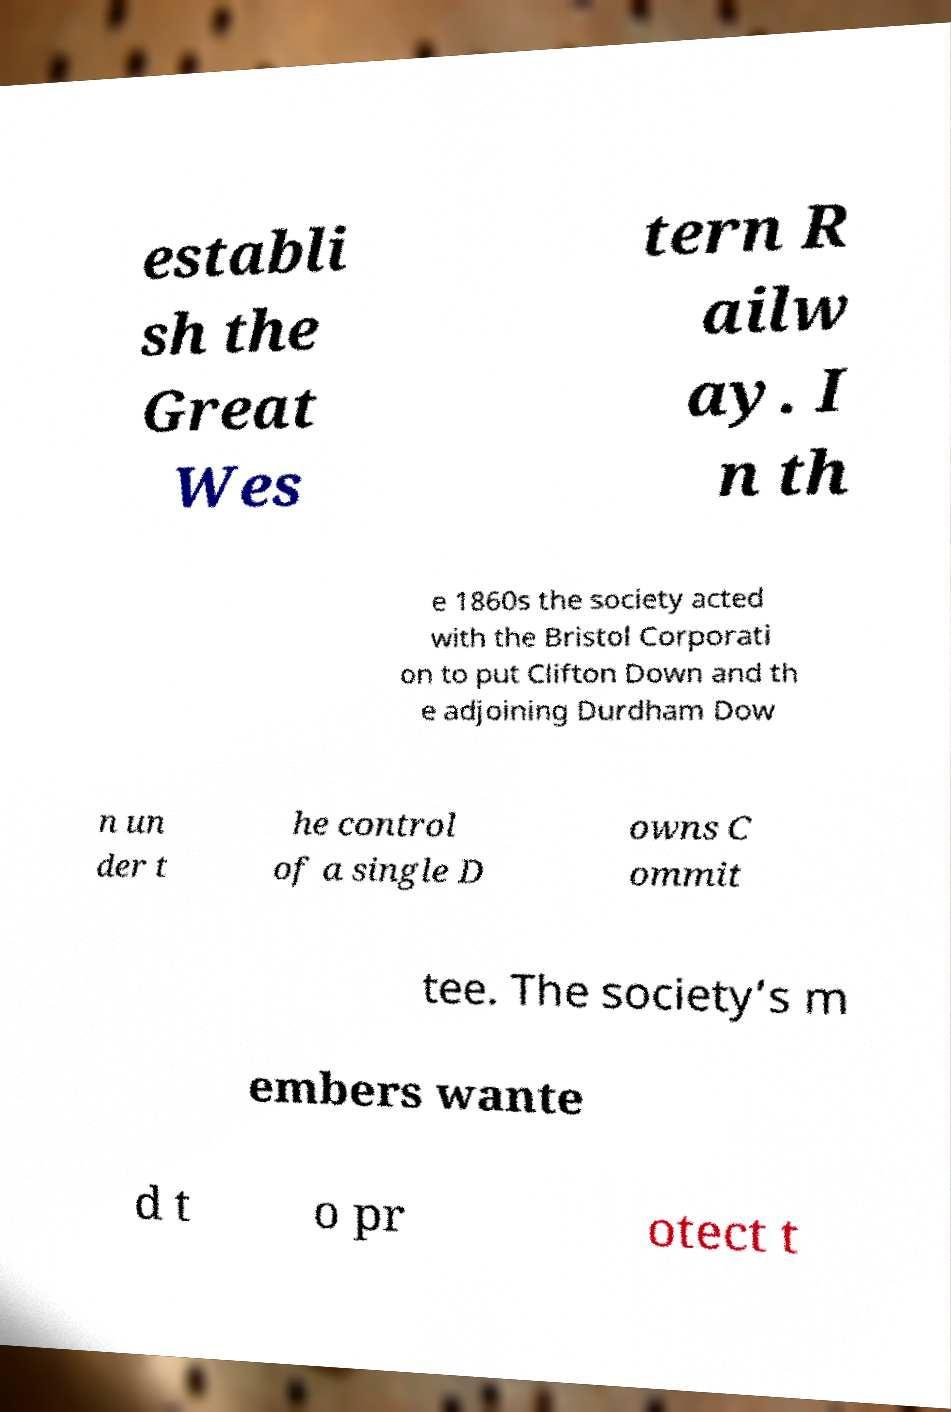Please identify and transcribe the text found in this image. establi sh the Great Wes tern R ailw ay. I n th e 1860s the society acted with the Bristol Corporati on to put Clifton Down and th e adjoining Durdham Dow n un der t he control of a single D owns C ommit tee. The society’s m embers wante d t o pr otect t 